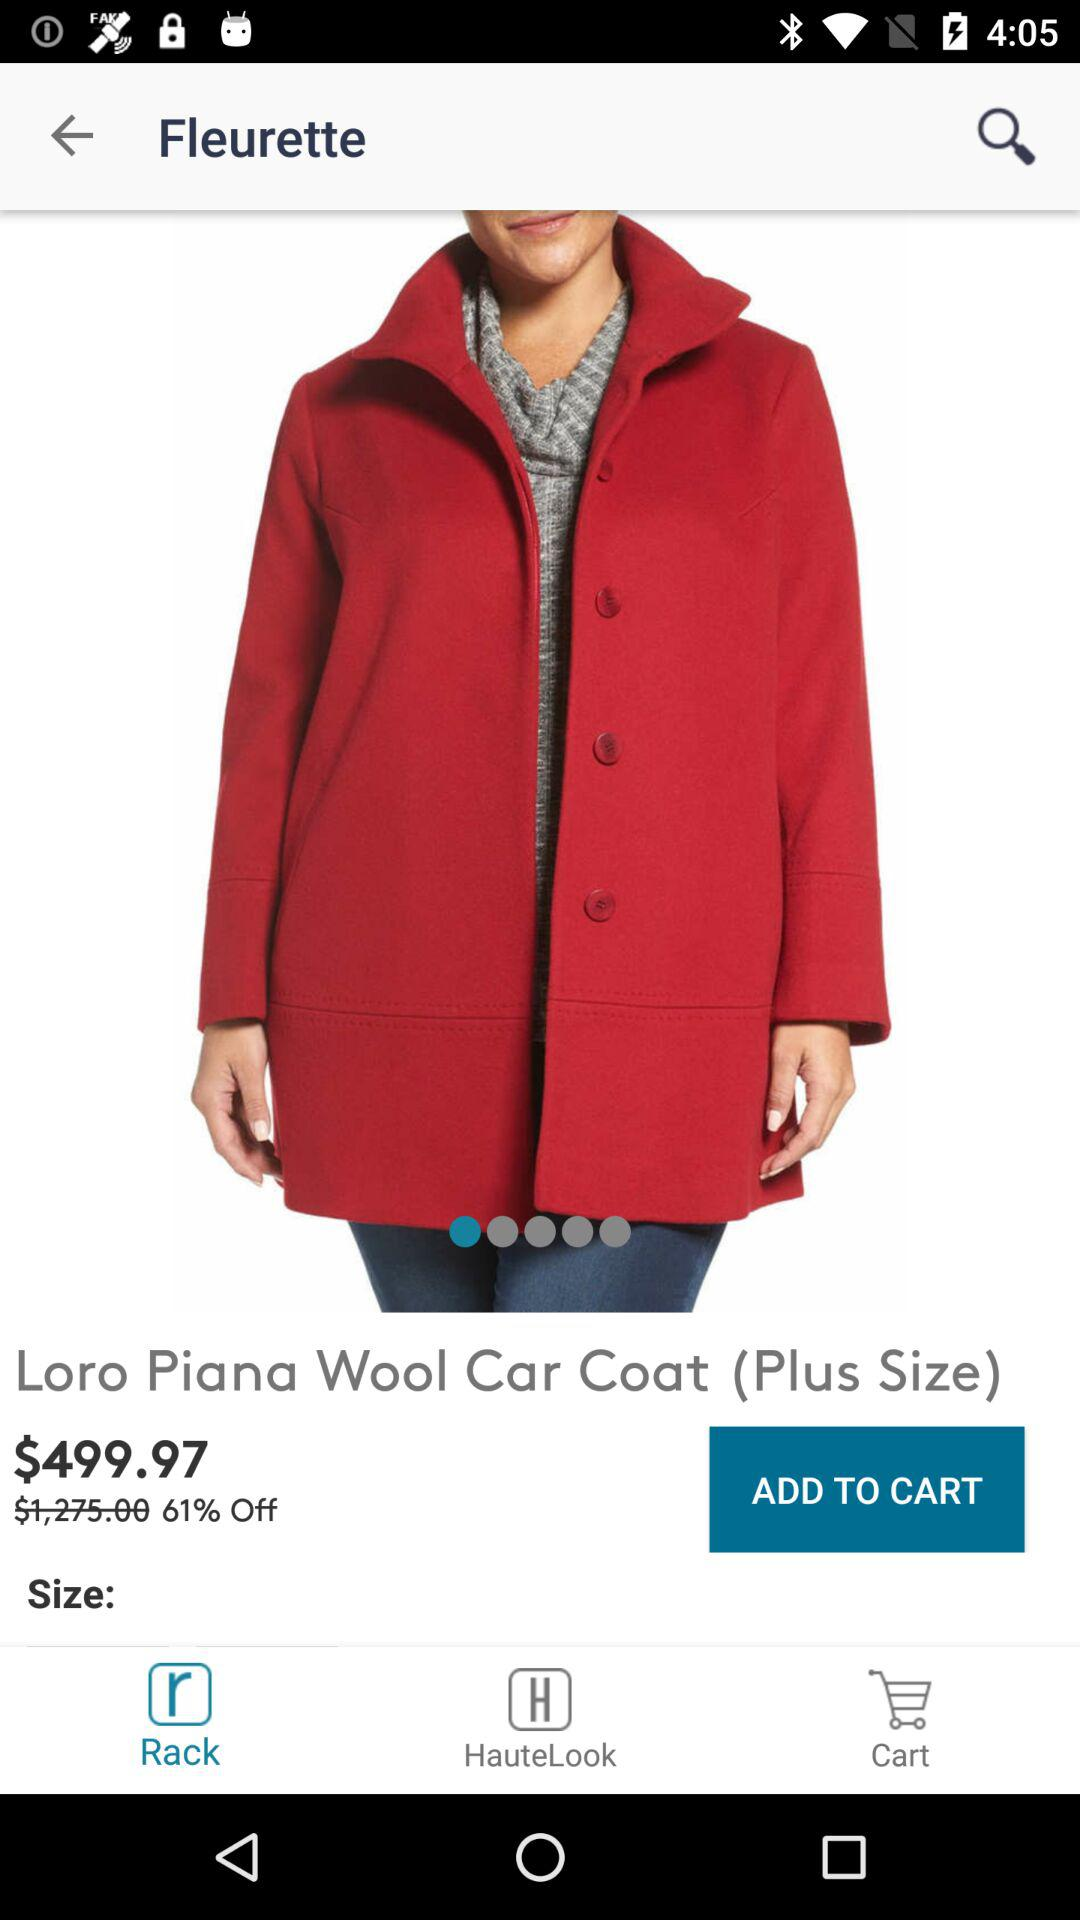What is the size of the product? The product is plus-sized. 